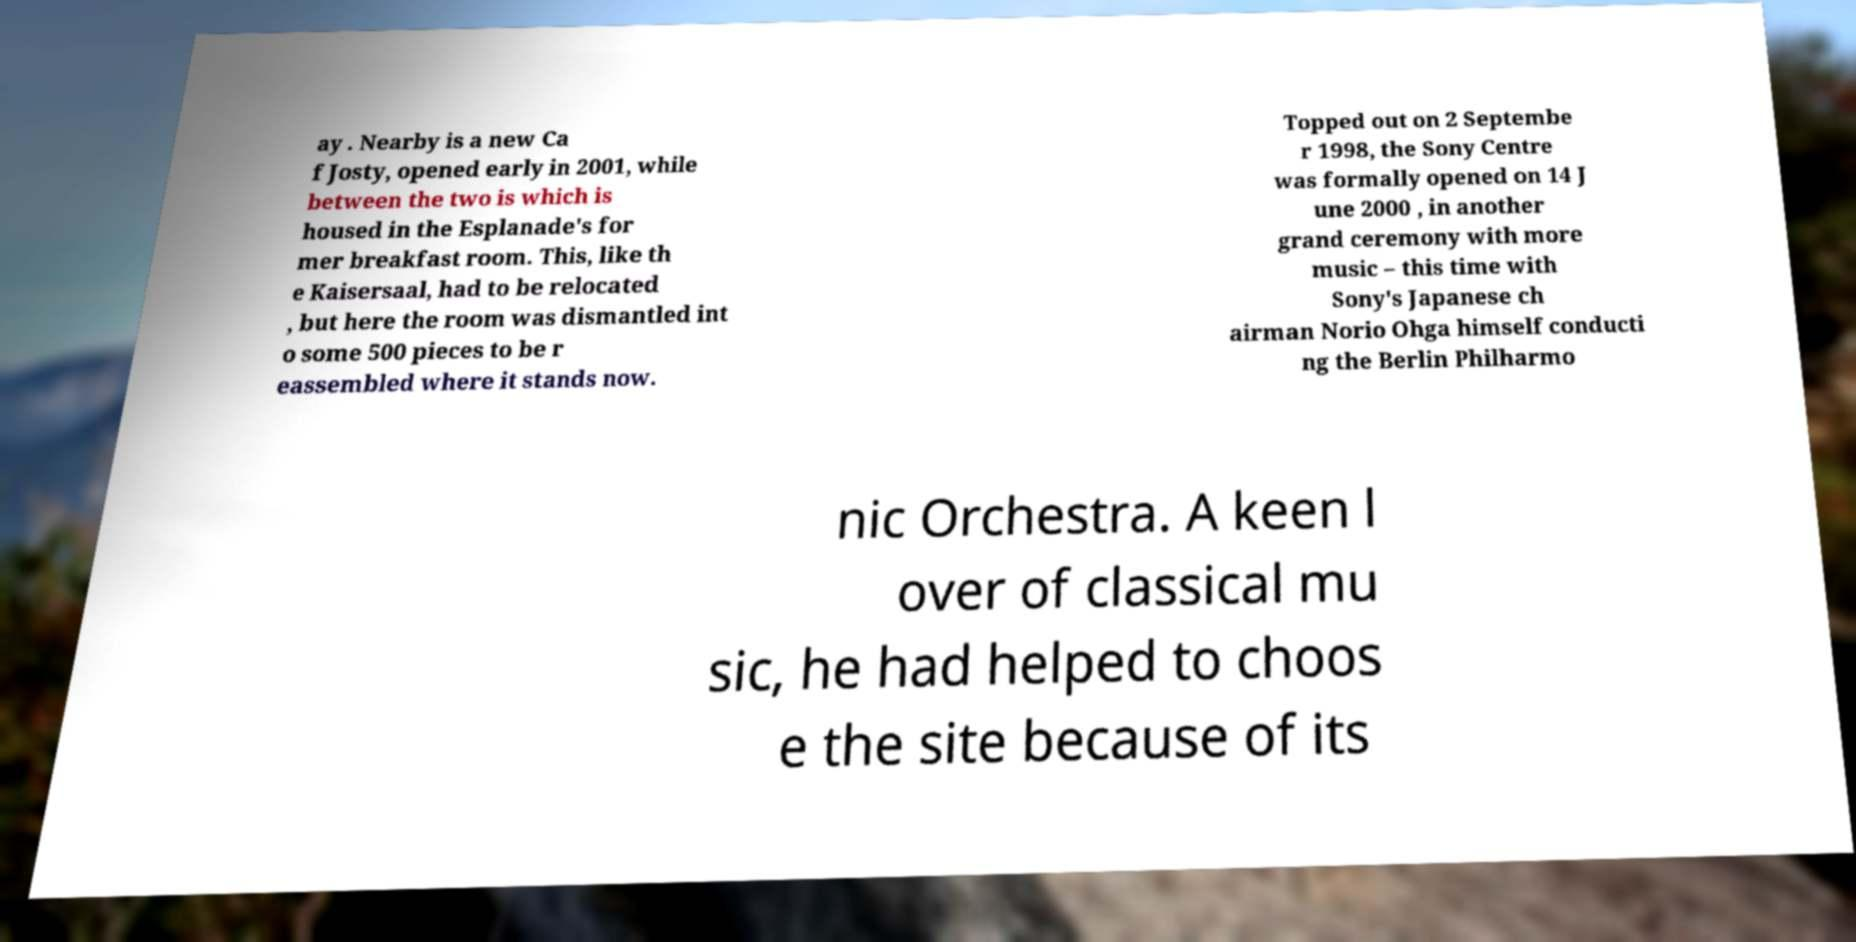Can you read and provide the text displayed in the image?This photo seems to have some interesting text. Can you extract and type it out for me? ay . Nearby is a new Ca f Josty, opened early in 2001, while between the two is which is housed in the Esplanade's for mer breakfast room. This, like th e Kaisersaal, had to be relocated , but here the room was dismantled int o some 500 pieces to be r eassembled where it stands now. Topped out on 2 Septembe r 1998, the Sony Centre was formally opened on 14 J une 2000 , in another grand ceremony with more music – this time with Sony's Japanese ch airman Norio Ohga himself conducti ng the Berlin Philharmo nic Orchestra. A keen l over of classical mu sic, he had helped to choos e the site because of its 